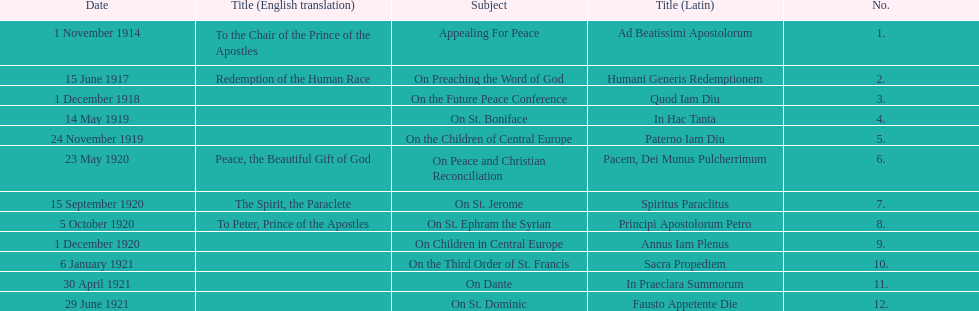What is the first english translation listed on the table? To the Chair of the Prince of the Apostles. 